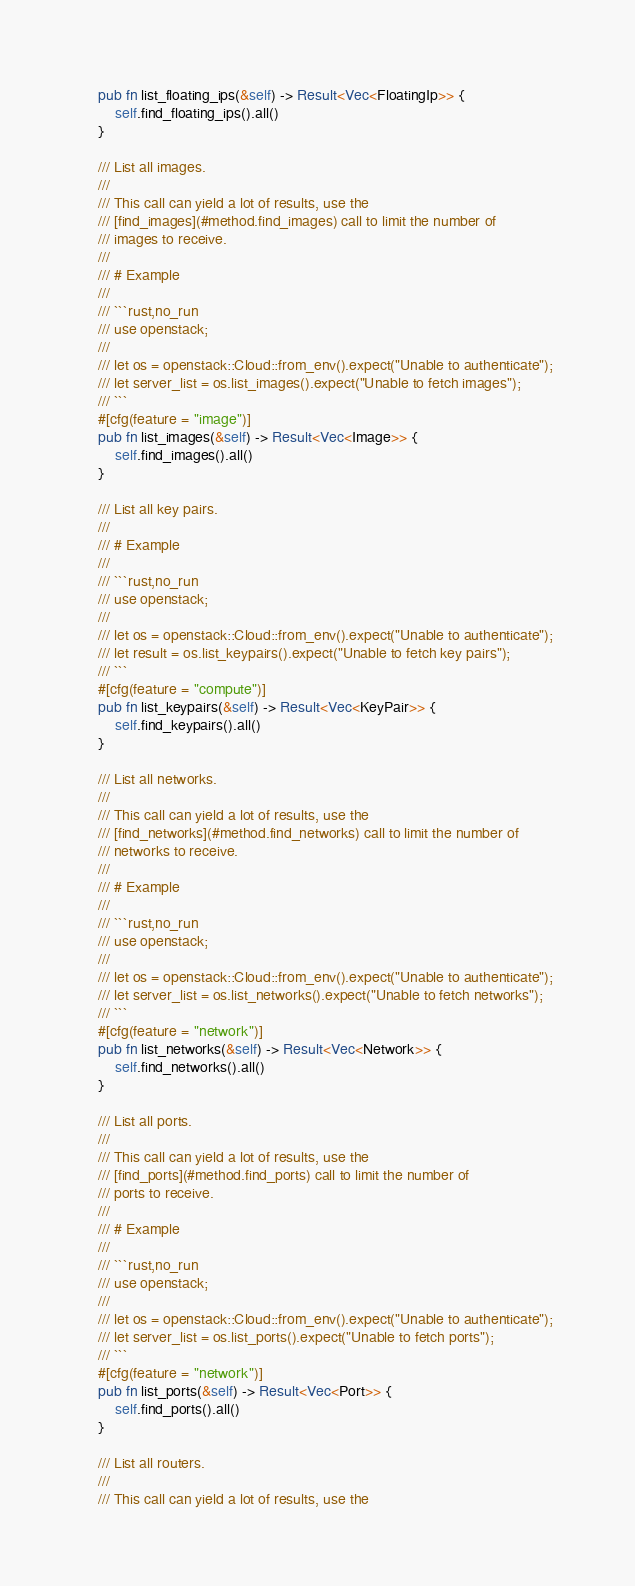Convert code to text. <code><loc_0><loc_0><loc_500><loc_500><_Rust_>    pub fn list_floating_ips(&self) -> Result<Vec<FloatingIp>> {
        self.find_floating_ips().all()
    }

    /// List all images.
    ///
    /// This call can yield a lot of results, use the
    /// [find_images](#method.find_images) call to limit the number of
    /// images to receive.
    ///
    /// # Example
    ///
    /// ```rust,no_run
    /// use openstack;
    ///
    /// let os = openstack::Cloud::from_env().expect("Unable to authenticate");
    /// let server_list = os.list_images().expect("Unable to fetch images");
    /// ```
    #[cfg(feature = "image")]
    pub fn list_images(&self) -> Result<Vec<Image>> {
        self.find_images().all()
    }

    /// List all key pairs.
    ///
    /// # Example
    ///
    /// ```rust,no_run
    /// use openstack;
    ///
    /// let os = openstack::Cloud::from_env().expect("Unable to authenticate");
    /// let result = os.list_keypairs().expect("Unable to fetch key pairs");
    /// ```
    #[cfg(feature = "compute")]
    pub fn list_keypairs(&self) -> Result<Vec<KeyPair>> {
        self.find_keypairs().all()
    }

    /// List all networks.
    ///
    /// This call can yield a lot of results, use the
    /// [find_networks](#method.find_networks) call to limit the number of
    /// networks to receive.
    ///
    /// # Example
    ///
    /// ```rust,no_run
    /// use openstack;
    ///
    /// let os = openstack::Cloud::from_env().expect("Unable to authenticate");
    /// let server_list = os.list_networks().expect("Unable to fetch networks");
    /// ```
    #[cfg(feature = "network")]
    pub fn list_networks(&self) -> Result<Vec<Network>> {
        self.find_networks().all()
    }

    /// List all ports.
    ///
    /// This call can yield a lot of results, use the
    /// [find_ports](#method.find_ports) call to limit the number of
    /// ports to receive.
    ///
    /// # Example
    ///
    /// ```rust,no_run
    /// use openstack;
    ///
    /// let os = openstack::Cloud::from_env().expect("Unable to authenticate");
    /// let server_list = os.list_ports().expect("Unable to fetch ports");
    /// ```
    #[cfg(feature = "network")]
    pub fn list_ports(&self) -> Result<Vec<Port>> {
        self.find_ports().all()
    }

    /// List all routers.
    ///
    /// This call can yield a lot of results, use the</code> 